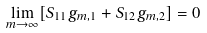<formula> <loc_0><loc_0><loc_500><loc_500>\lim _ { m \rightarrow \infty } [ { S } _ { 1 1 } g _ { m , 1 } + { S } _ { 1 2 } g _ { m , 2 } ] = 0</formula> 